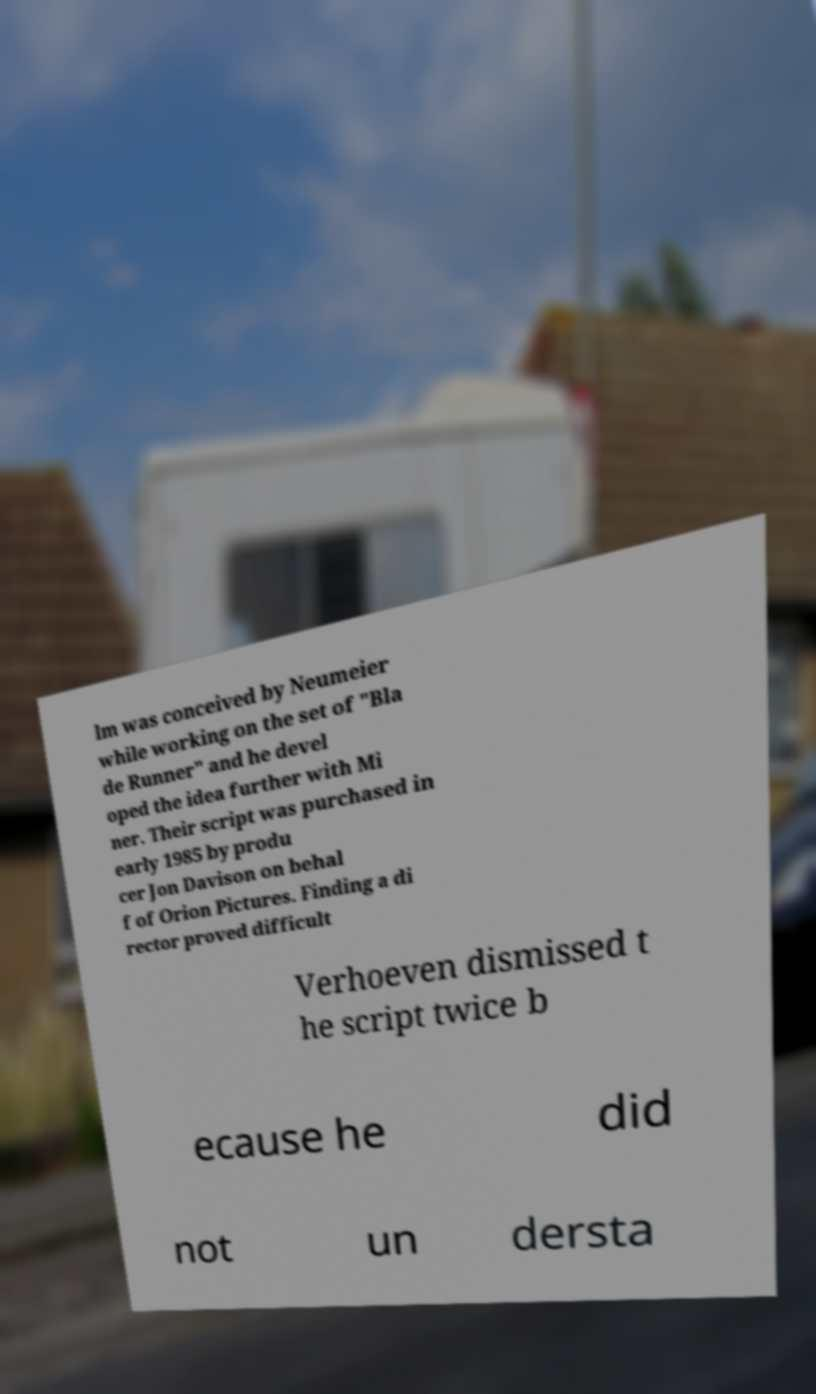Can you accurately transcribe the text from the provided image for me? lm was conceived by Neumeier while working on the set of "Bla de Runner" and he devel oped the idea further with Mi ner. Their script was purchased in early 1985 by produ cer Jon Davison on behal f of Orion Pictures. Finding a di rector proved difficult Verhoeven dismissed t he script twice b ecause he did not un dersta 